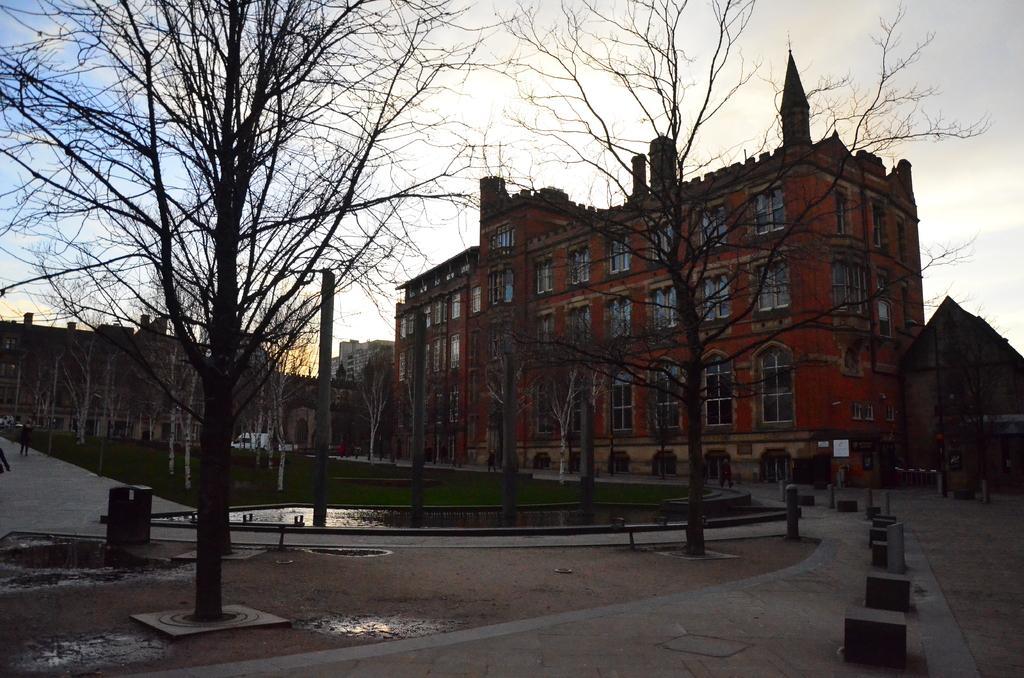Could you give a brief overview of what you see in this image? In this image, we can see so many buildings, walls, glass windows, trees, poles, water and walkways. Background there is a sky. Here we can see grass. 